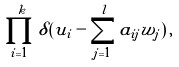<formula> <loc_0><loc_0><loc_500><loc_500>\prod _ { i = 1 } ^ { k } \delta ( u _ { i } - \sum _ { j = 1 } ^ { l } a _ { i j } w _ { j } ) \, ,</formula> 